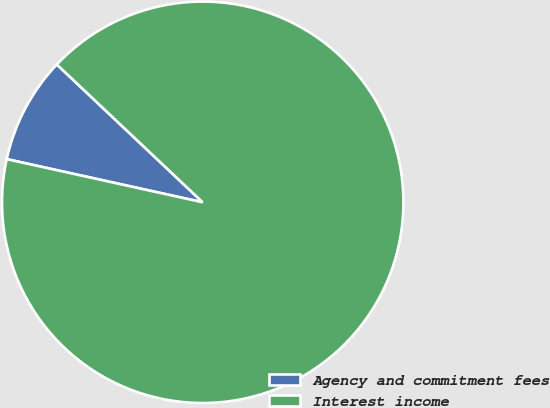Convert chart. <chart><loc_0><loc_0><loc_500><loc_500><pie_chart><fcel>Agency and commitment fees<fcel>Interest income<nl><fcel>8.6%<fcel>91.4%<nl></chart> 